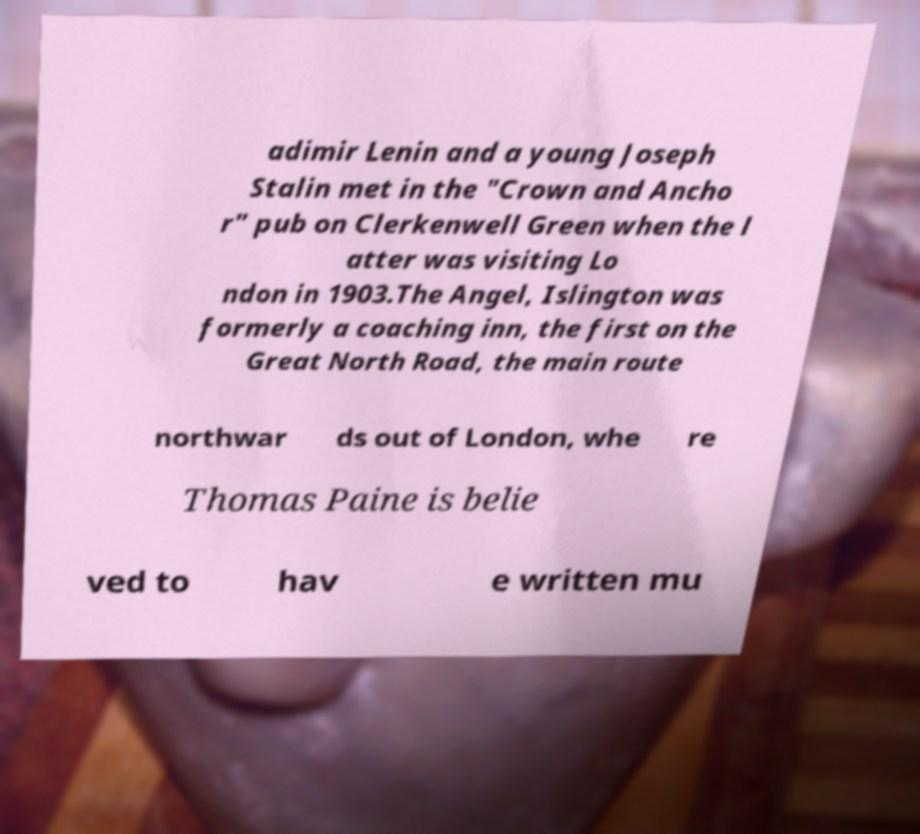Please identify and transcribe the text found in this image. adimir Lenin and a young Joseph Stalin met in the "Crown and Ancho r" pub on Clerkenwell Green when the l atter was visiting Lo ndon in 1903.The Angel, Islington was formerly a coaching inn, the first on the Great North Road, the main route northwar ds out of London, whe re Thomas Paine is belie ved to hav e written mu 